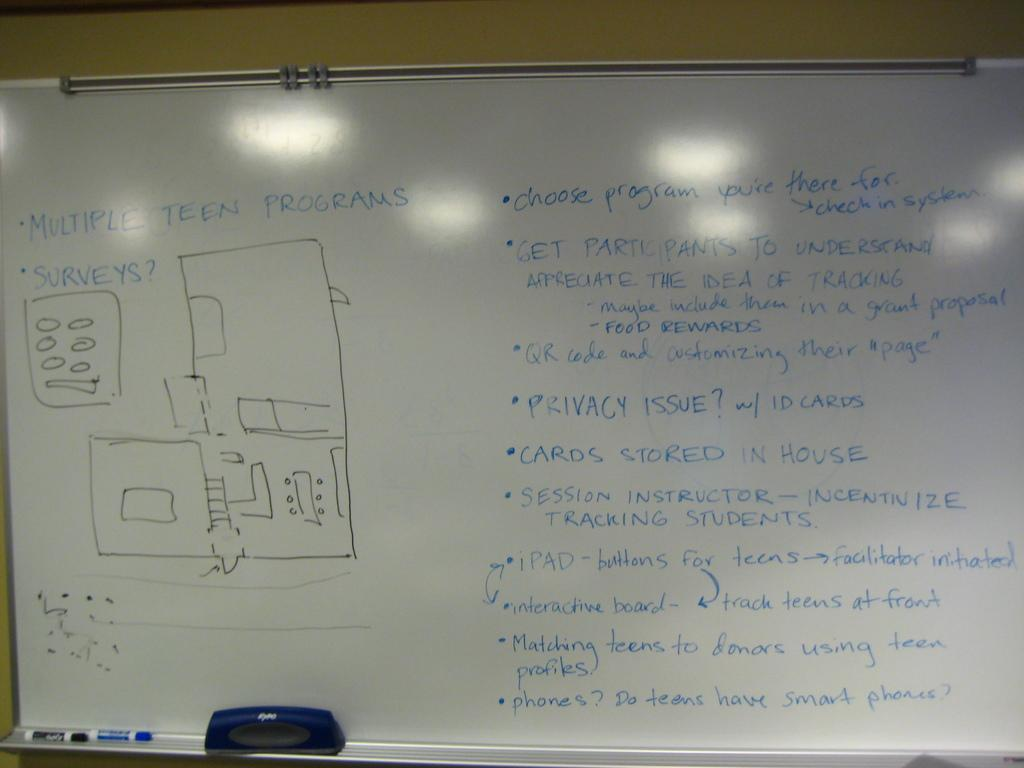<image>
Describe the image concisely. A white board has several bullet points about the Multiple Teen Porgrams and how they work. 